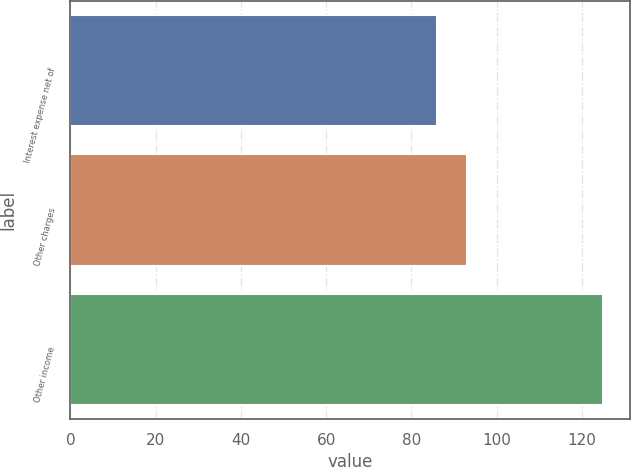Convert chart. <chart><loc_0><loc_0><loc_500><loc_500><bar_chart><fcel>Interest expense net of<fcel>Other charges<fcel>Other income<nl><fcel>86<fcel>93<fcel>125<nl></chart> 